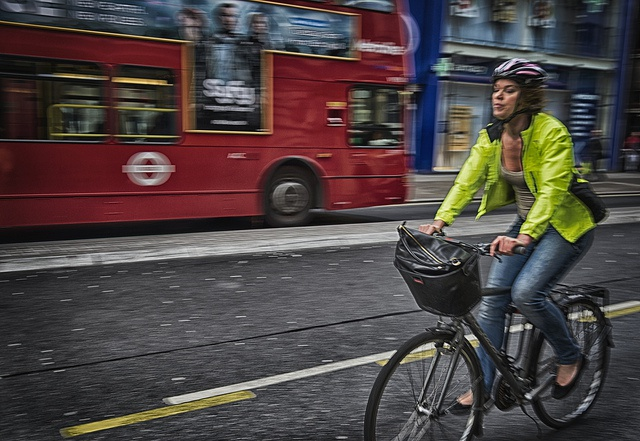Describe the objects in this image and their specific colors. I can see bus in black, maroon, gray, and brown tones, bicycle in black, gray, and darkgray tones, people in black, darkgreen, olive, and gray tones, handbag in black, gray, and darkgray tones, and backpack in black, gray, and darkgreen tones in this image. 